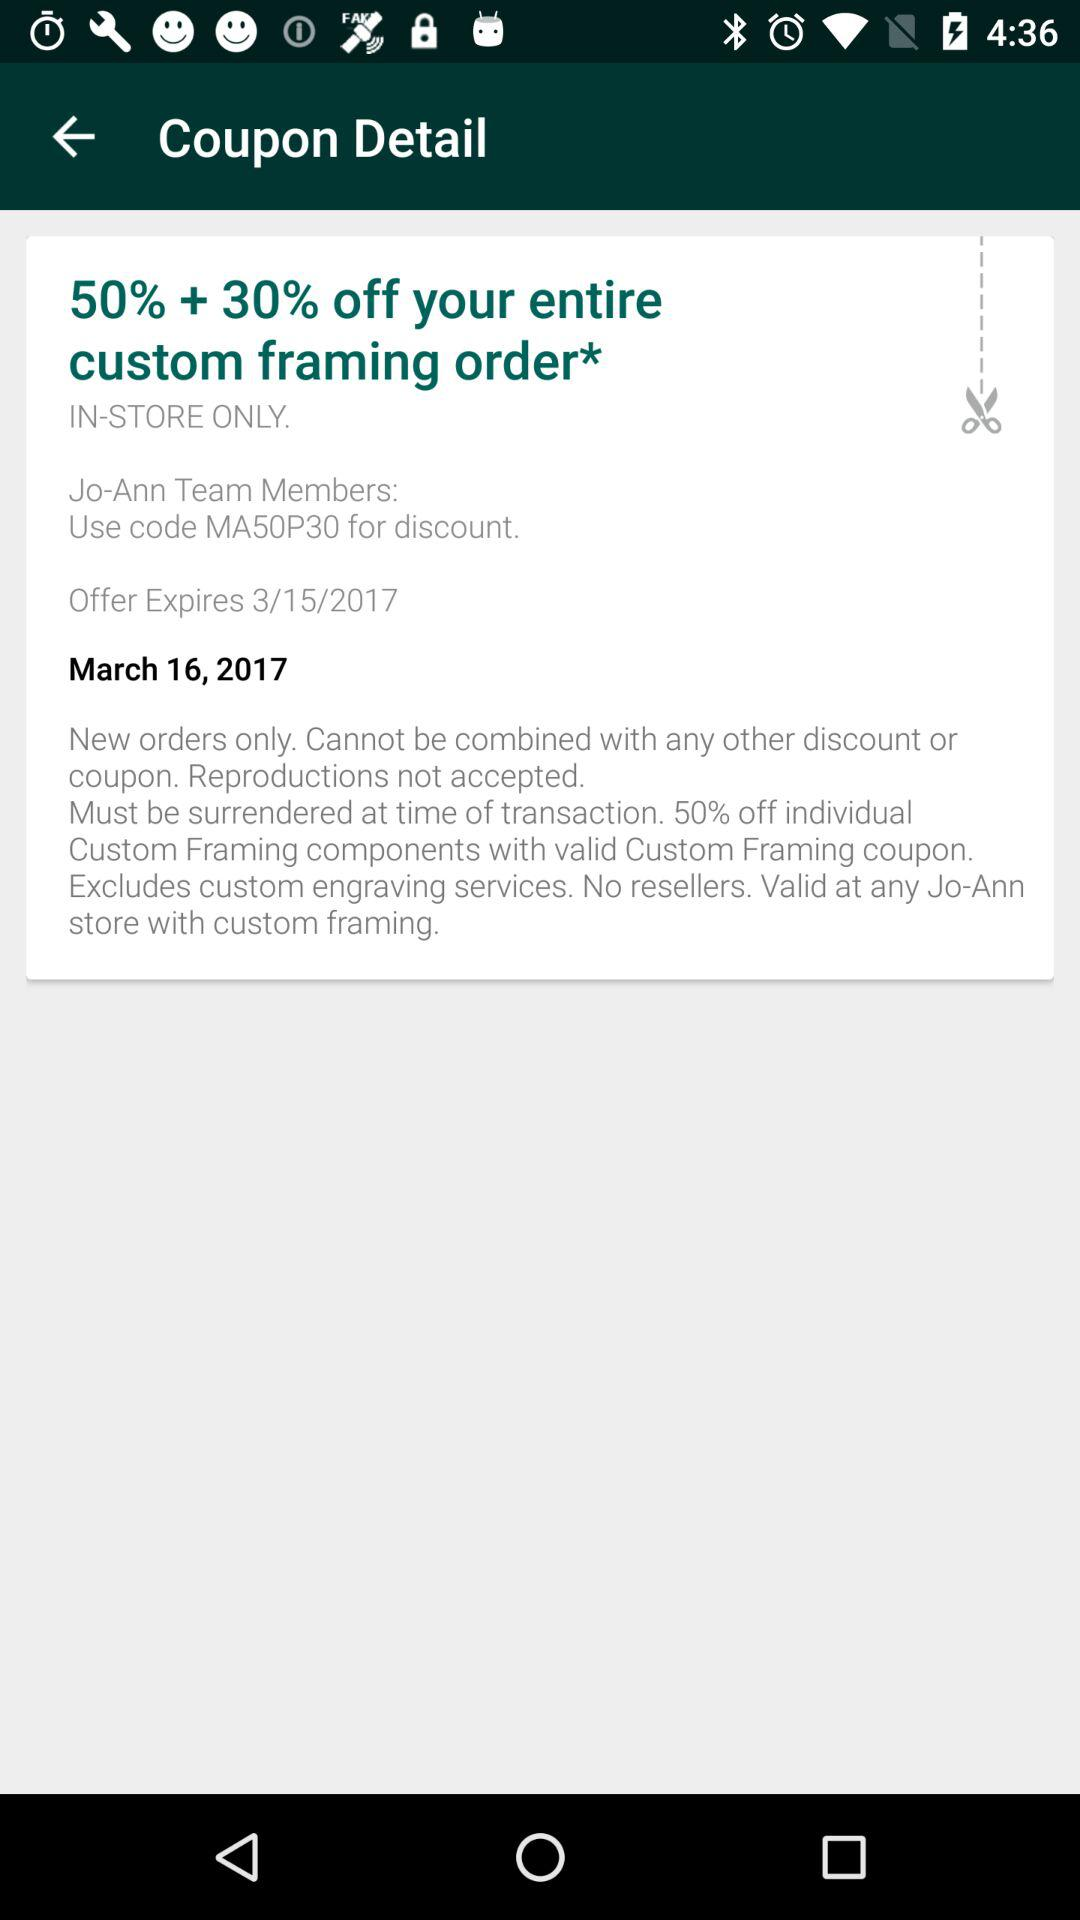How much off is the coupon?
Answer the question using a single word or phrase. 50% + 30% 